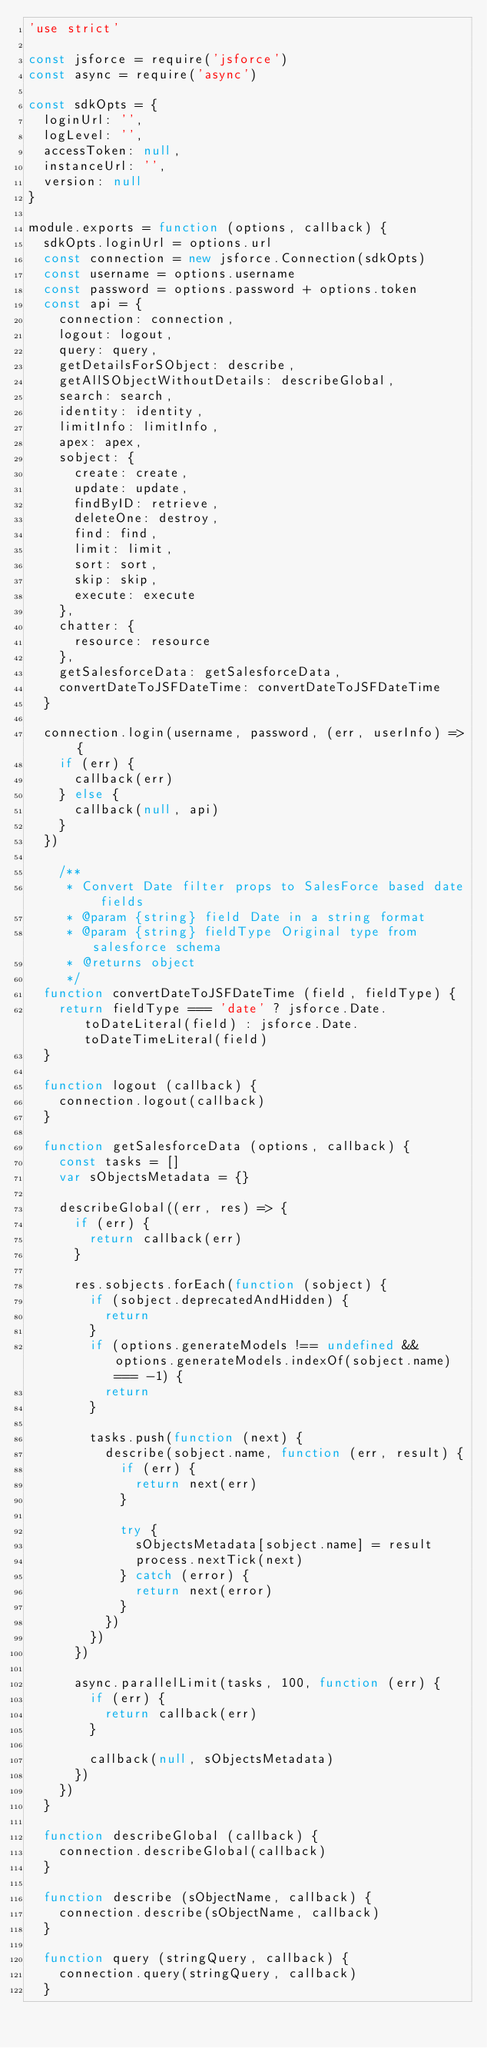<code> <loc_0><loc_0><loc_500><loc_500><_JavaScript_>'use strict'

const jsforce = require('jsforce')
const async = require('async')

const sdkOpts = {
  loginUrl: '',
  logLevel: '',
  accessToken: null,
  instanceUrl: '',
  version: null
}

module.exports = function (options, callback) {
  sdkOpts.loginUrl = options.url
  const connection = new jsforce.Connection(sdkOpts)
  const username = options.username
  const password = options.password + options.token
  const api = {
    connection: connection,
    logout: logout,
    query: query,
    getDetailsForSObject: describe,
    getAllSObjectWithoutDetails: describeGlobal,
    search: search,
    identity: identity,
    limitInfo: limitInfo,
    apex: apex,
    sobject: {
      create: create,
      update: update,
      findByID: retrieve,
      deleteOne: destroy,
      find: find,
      limit: limit,
      sort: sort,
      skip: skip,
      execute: execute
    },
    chatter: {
      resource: resource
    },
    getSalesforceData: getSalesforceData,
    convertDateToJSFDateTime: convertDateToJSFDateTime
  }

  connection.login(username, password, (err, userInfo) => {
    if (err) {
      callback(err)
    } else {
      callback(null, api)
    }
  })

    /**
     * Convert Date filter props to SalesForce based date fields
     * @param {string} field Date in a string format
     * @param {string} fieldType Original type from salesforce schema
     * @returns object
     */
  function convertDateToJSFDateTime (field, fieldType) {
    return fieldType === 'date' ? jsforce.Date.toDateLiteral(field) : jsforce.Date.toDateTimeLiteral(field)
  }

  function logout (callback) {
    connection.logout(callback)
  }

  function getSalesforceData (options, callback) {
    const tasks = []
    var sObjectsMetadata = {}

    describeGlobal((err, res) => {
      if (err) {
        return callback(err)
      }

      res.sobjects.forEach(function (sobject) {
        if (sobject.deprecatedAndHidden) {
          return
        }
        if (options.generateModels !== undefined && options.generateModels.indexOf(sobject.name) === -1) {
          return
        }

        tasks.push(function (next) {
          describe(sobject.name, function (err, result) {
            if (err) {
              return next(err)
            }

            try {
              sObjectsMetadata[sobject.name] = result
              process.nextTick(next)
            } catch (error) {
              return next(error)
            }
          })
        })
      })

      async.parallelLimit(tasks, 100, function (err) {
        if (err) {
          return callback(err)
        }

        callback(null, sObjectsMetadata)
      })
    })
  }

  function describeGlobal (callback) {
    connection.describeGlobal(callback)
  }

  function describe (sObjectName, callback) {
    connection.describe(sObjectName, callback)
  }

  function query (stringQuery, callback) {
    connection.query(stringQuery, callback)
  }
</code> 